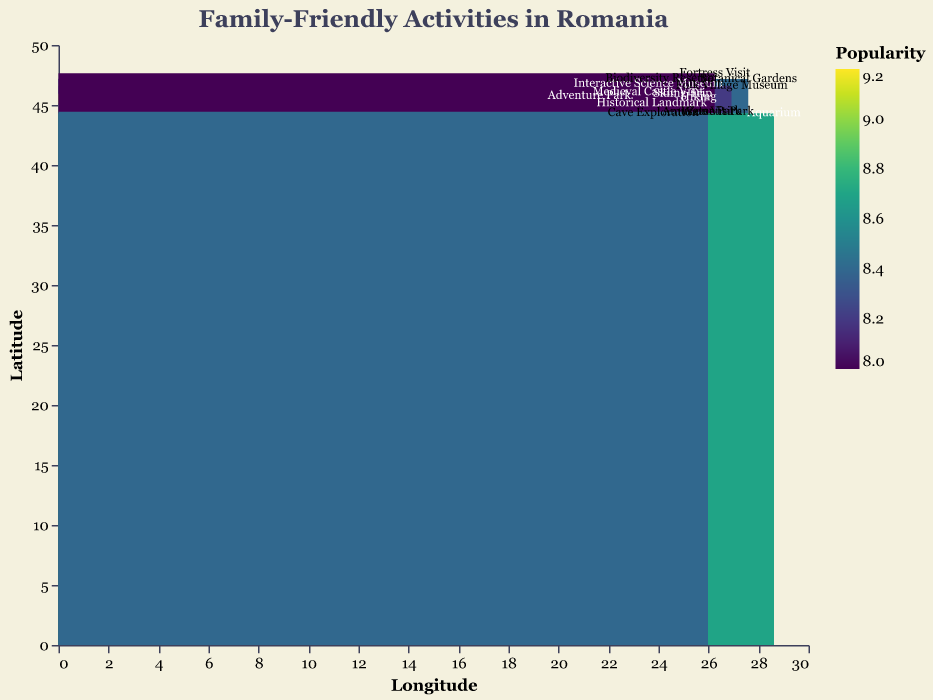What is the title of the figure? The title of the figure is displayed at the top, indicating the content of the heatmap. The text reads "Family-Friendly Activities in Romania".
Answer: Family-Friendly Activities in Romania Which activity has the highest popularity rating? To find this, look at the color shading and numeric values in the popularity key. The highest popularity rating is seen for the "Skiing Trip" at Poiana Brașov with a popularity of 9.2.
Answer: Skiing Trip at Poiana Brașov Which latitude and longitude values correspond to the Medieval Castle Visit? By locating the activity "Medieval Castle Visit" on the heatmap, the coordinates are found at Latitude 46.067 and Longitude 23.5804.
Answer: Latitude 46.067, Longitude 23.5804 What is the color associated with the least popular activity? The least popular activity, with the lowest popularity value of 8.0, is the "Fortress Visit" at Suceava Fortress. The corresponding shade is the lightest in the viridis color scale.
Answer: Lightest shade of the viridis scale Which activity is closest in geographic proximity to Bucharest Zoo? By comparing the coordinates, the activity closest to Bucharest Zoo (Latitude 44.4343, Longitude 26.1024) is the Water Park at Divertiland Water Park (Latitude 44.4536, Longitude 26.1042)
Answer: Water Park at Divertiland Water Park What is the average popularity of activities located at a latitude above 46? Sum the popularity ratings of activities above latitude 46: Interactive Science Museum (9.1), Botanical Gardens (8.4), Folk Village Museum (8.2), Biodiversity Reserve (8.1), and Fortress Visit (8.0). The average is (9.1+8.4+8.2+8.1+8.0) / 5 = 8.36
Answer: 8.36 How many activities are represented in the heatmap? Count the total number of different activity entries shown on the heatmap. There are 14 activities represented, each at different locations.
Answer: 14 Which activity has a higher popularity rating, Hiking or Adventure Park? Compare the popularity ratings of Hiking (9.0) and Adventure Park (8.9). Hiking has a higher popularity rating.
Answer: Hiking What is the most popular activity along the longitude 26? Activities along longitude 26: Bucharest Zoo (8.5), Divertiland Water Park (8.3), Amusement Park (8.4). Bucharest Zoo has the highest popularity rating of 8.5.
Answer: Bucharest Zoo Which activity is located at the southwesternmost point on the map? Identify the activity with the lowest (most negative) latitude and longitude values. This is the Cave Exploration at Pestera Muierilor with coordinates Latitude 44.3302, Longitude 23.7949.
Answer: Cave Exploration at Pestera Muierilor 